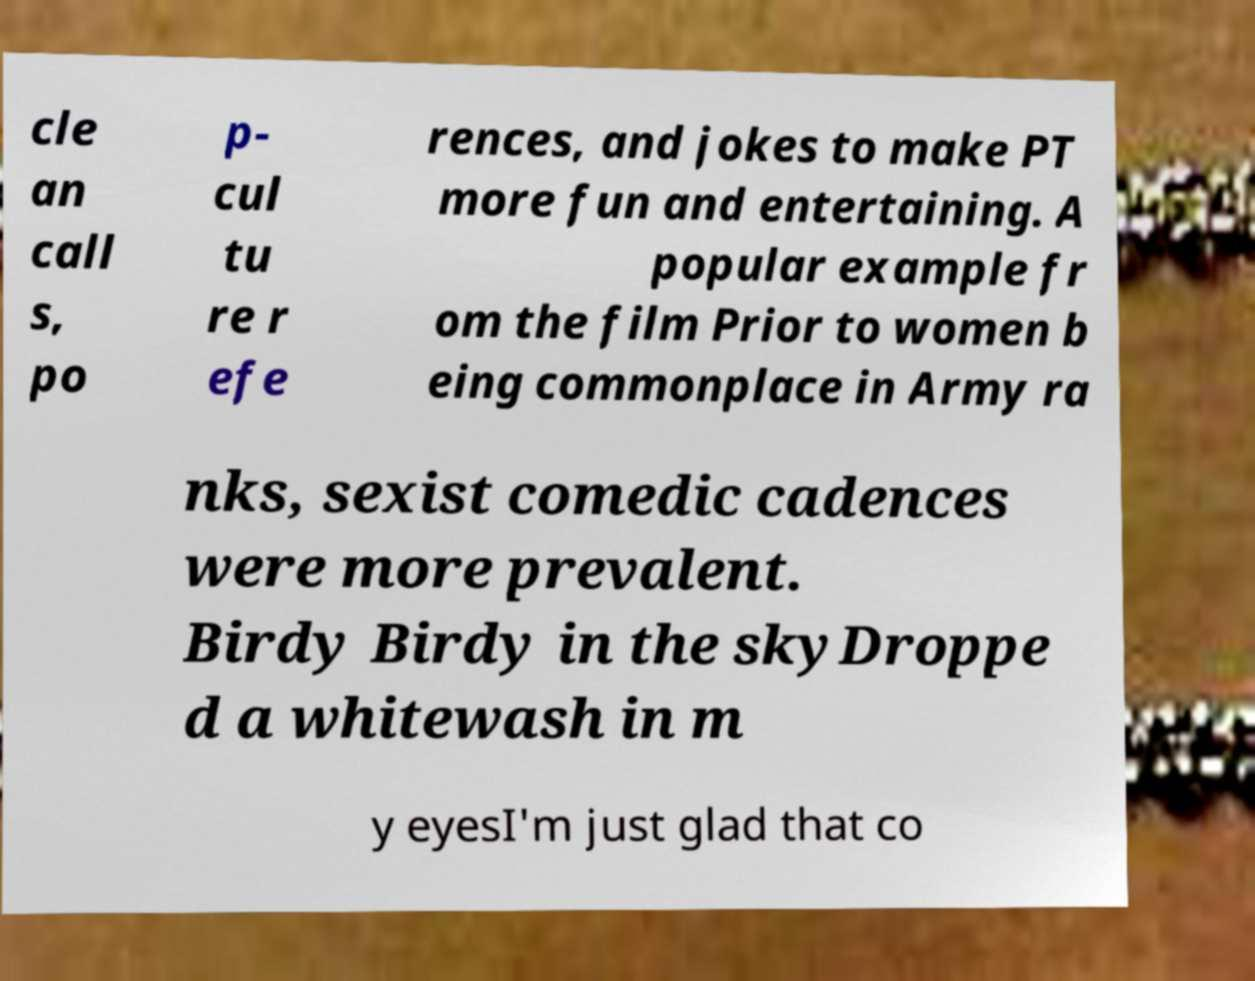Can you read and provide the text displayed in the image?This photo seems to have some interesting text. Can you extract and type it out for me? cle an call s, po p- cul tu re r efe rences, and jokes to make PT more fun and entertaining. A popular example fr om the film Prior to women b eing commonplace in Army ra nks, sexist comedic cadences were more prevalent. Birdy Birdy in the skyDroppe d a whitewash in m y eyesI'm just glad that co 